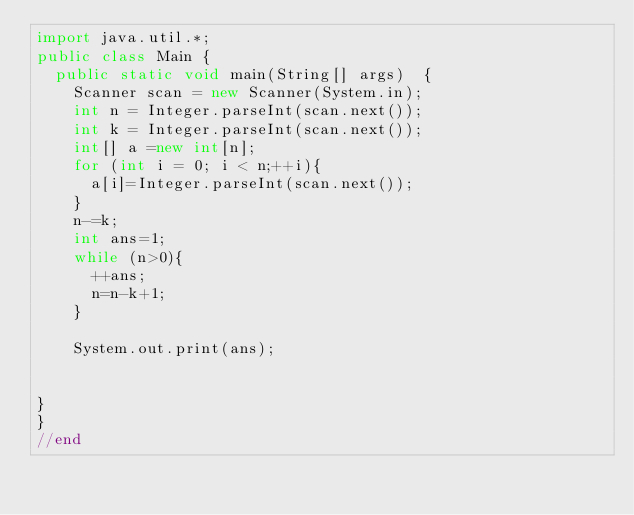Convert code to text. <code><loc_0><loc_0><loc_500><loc_500><_Java_>import java.util.*;
public class Main {
	public static void main(String[] args)  {
		Scanner scan = new Scanner(System.in);
		int n = Integer.parseInt(scan.next());
		int k = Integer.parseInt(scan.next());
		int[] a =new int[n];
		for (int i = 0; i < n;++i){
			a[i]=Integer.parseInt(scan.next());
		}
		n-=k;
		int ans=1;
		while (n>0){
			++ans;
			n=n-k+1;
		}

		System.out.print(ans);


}
}
//end</code> 